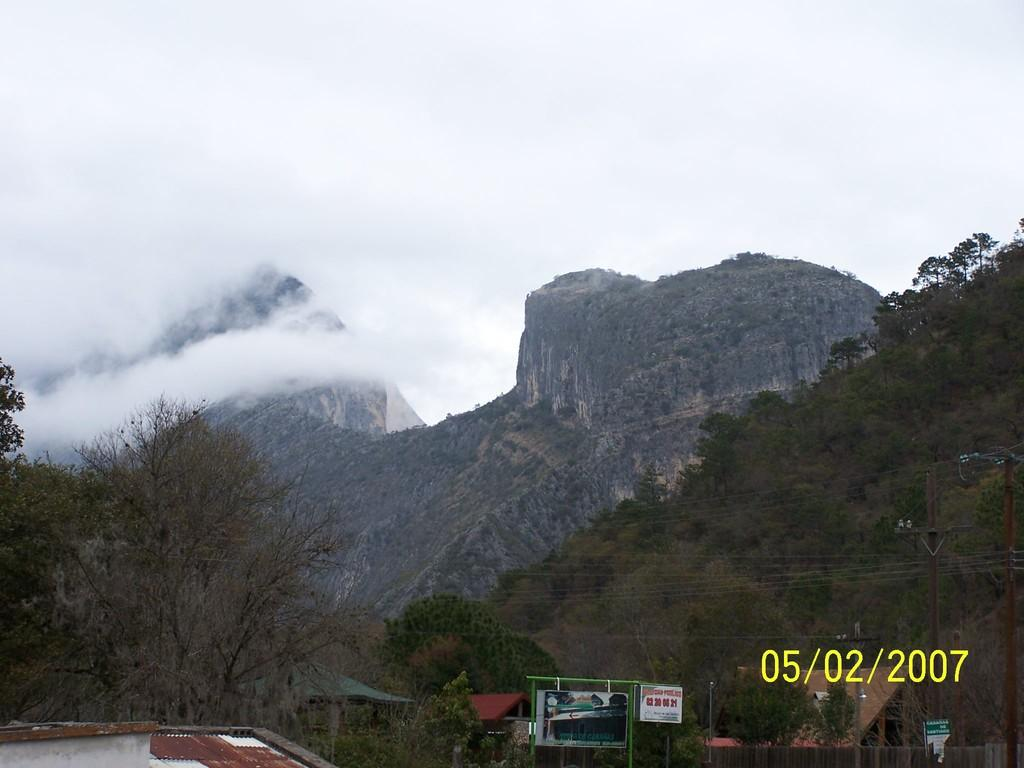What can be seen in the sky in the image? The sky is visible in the image. What type of natural features are present in the image? There are hills and trees visible in the image. What type of man-made structures can be seen in the image? There are sheds, information boards, electric poles, and electric cables present in the image. Can you describe the weather conditions in the image? The presence of clouds suggests that the weather might be partly cloudy. What type of garden can be seen in the image? There is no garden present in the image. What type of insurance policy is being advertised on the information boards in the image? There is no information about insurance policies on the information boards in the image. 